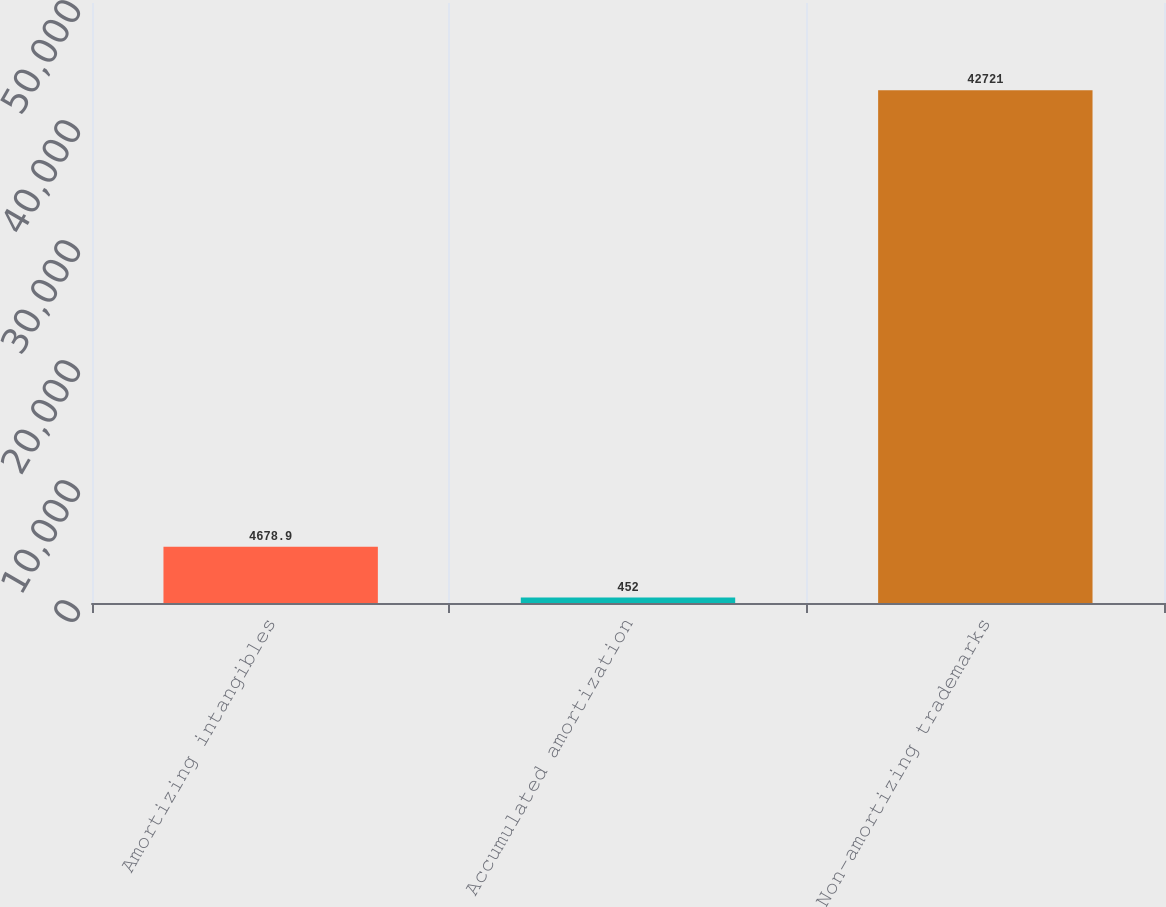Convert chart. <chart><loc_0><loc_0><loc_500><loc_500><bar_chart><fcel>Amortizing intangibles<fcel>Accumulated amortization<fcel>Non-amortizing trademarks<nl><fcel>4678.9<fcel>452<fcel>42721<nl></chart> 